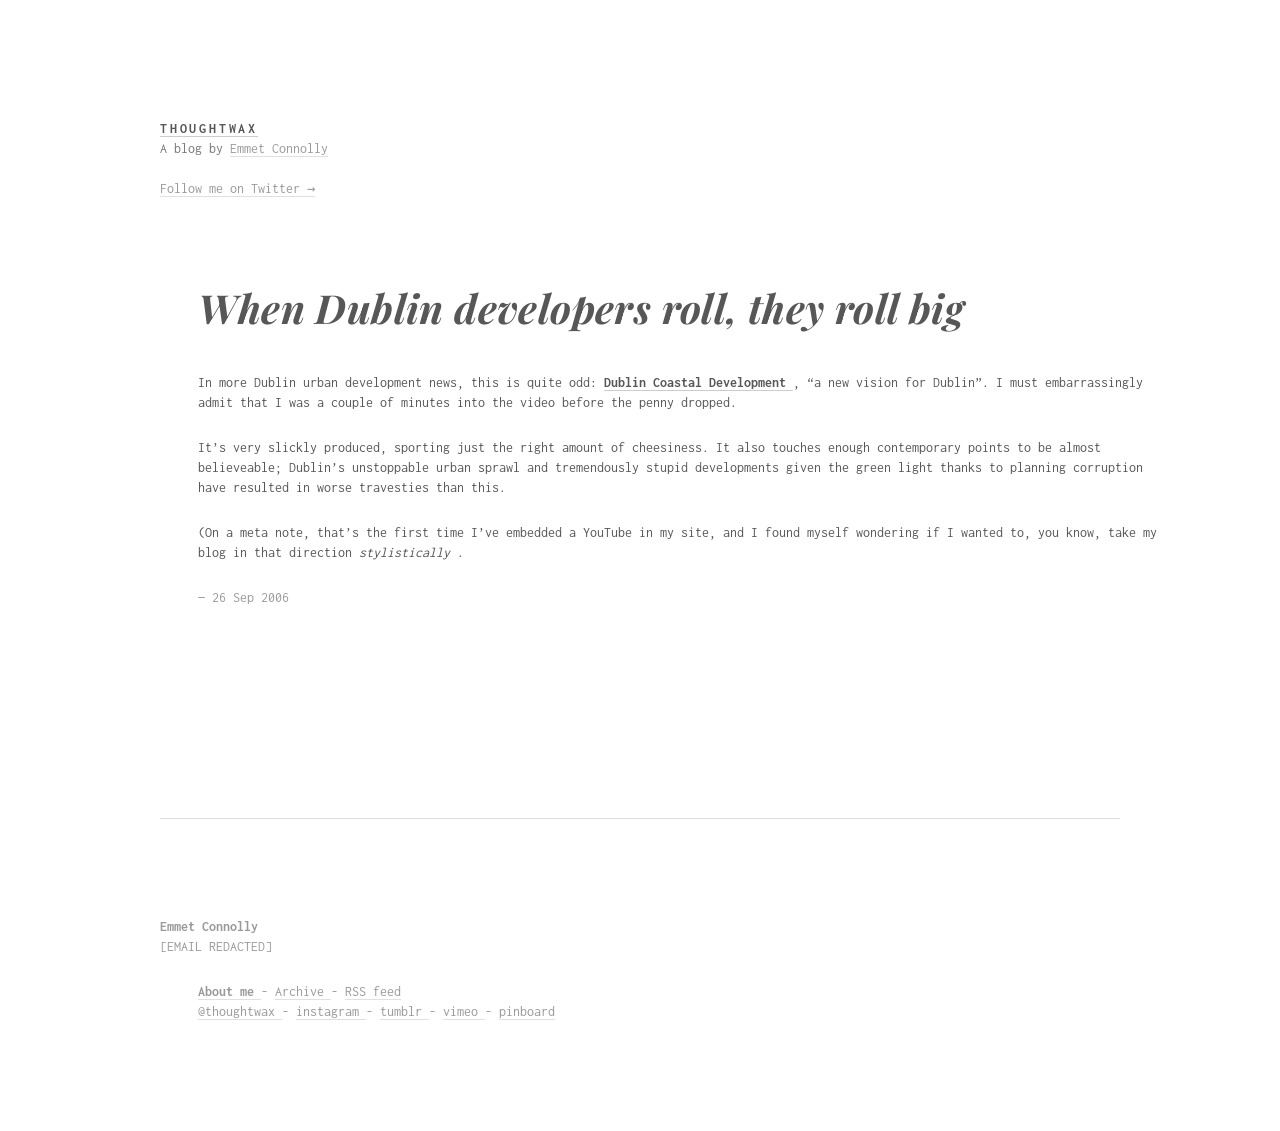What are some design tips to achieve the minimalistic style shown in this blog layout? To achieve a minimalistic style like the one shown in the image, focus on a clean and uncluttered layout. Use ample white space to give elements breathing room. Stick to a monochrome or limited color palette. Use typography to create visual interest and hierarchy—select modern, readable fonts and ensure text is well-spaced. Simplify navigation and only include essential elements to maintain simplicity and user focus. 